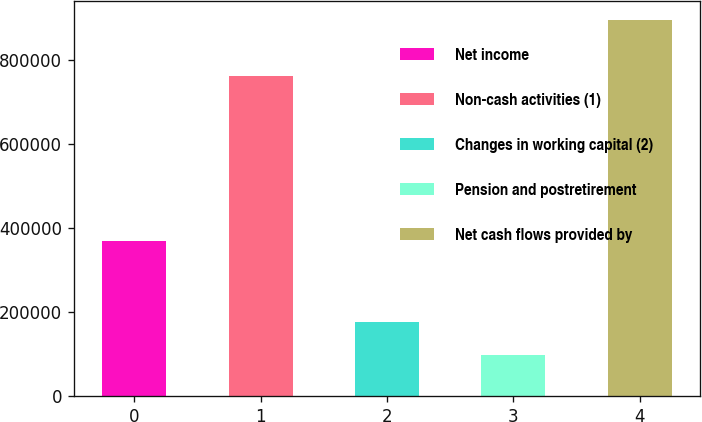Convert chart. <chart><loc_0><loc_0><loc_500><loc_500><bar_chart><fcel>Net income<fcel>Non-cash activities (1)<fcel>Changes in working capital (2)<fcel>Pension and postretirement<fcel>Net cash flows provided by<nl><fcel>369264<fcel>761772<fcel>177366<fcel>97500<fcel>896162<nl></chart> 